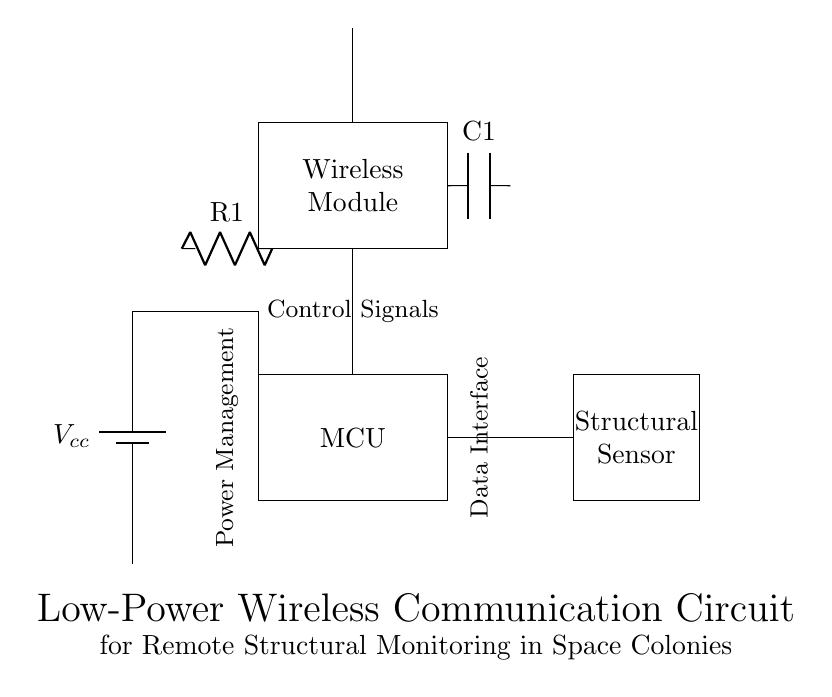What type of sensor is used in the circuit? The diagram indicates a "Structural Sensor" that is designed to monitor structural integrity. This label is directly visible within the rectangle representing the sensor.
Answer: Structural Sensor What component supplies power to the circuit? The circuit utilizes a "Battery" to provide voltage. This is shown as the first component in the diagram labeled as Vcc, which is attached to the power management section.
Answer: Battery How many main components are there in the circuit diagram? There are four main components: the battery, microcontroller (MCU), sensor, and wireless module. This is counted by identifying the large rectangles given in the diagram.
Answer: Four What is the purpose of the wireless module? The wireless module facilitates communication, enabling data transfer about the structural integrity. This can be inferred by its designation in the diagram labeled as "Wireless Module" and its connection to the antenna for transmitting signals.
Answer: Communication What is the function of the antenna in this circuit? The antenna allows for wireless transmission of data collected from the structural sensor to a remote location. This function is implied by its placement at the top of the wireless module, which indicates it transmits signals.
Answer: Transmission What is the role of the resistor represented in the circuit? The resistor, labeled R1, is typically used for managing current flow or voltage levels within the circuit, ensuring that the components operate within specified guidelines. This can be inferred from standard circuit usage and its position relative to the power management section.
Answer: Current management Which component is likely responsible for data processing in the circuit? The microcontroller (MCU) is responsible for processing the data obtained from the structural sensor. This is apparent from its labeled rectangle in the diagram, hinting at its central role in computation and control.
Answer: Microcontroller 